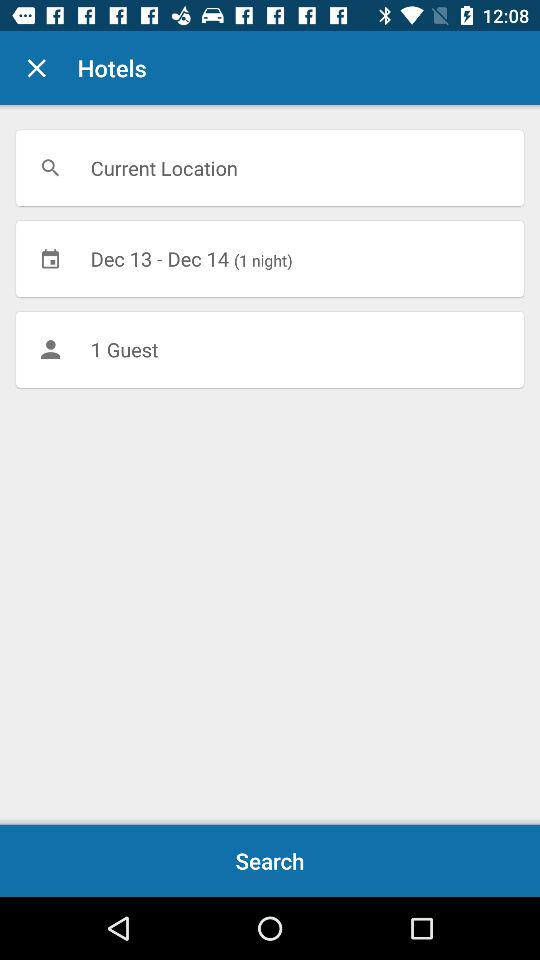For which date has the booking being done? The booking is being done for December 13–14. 